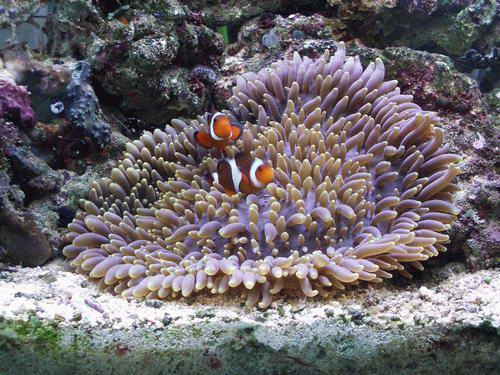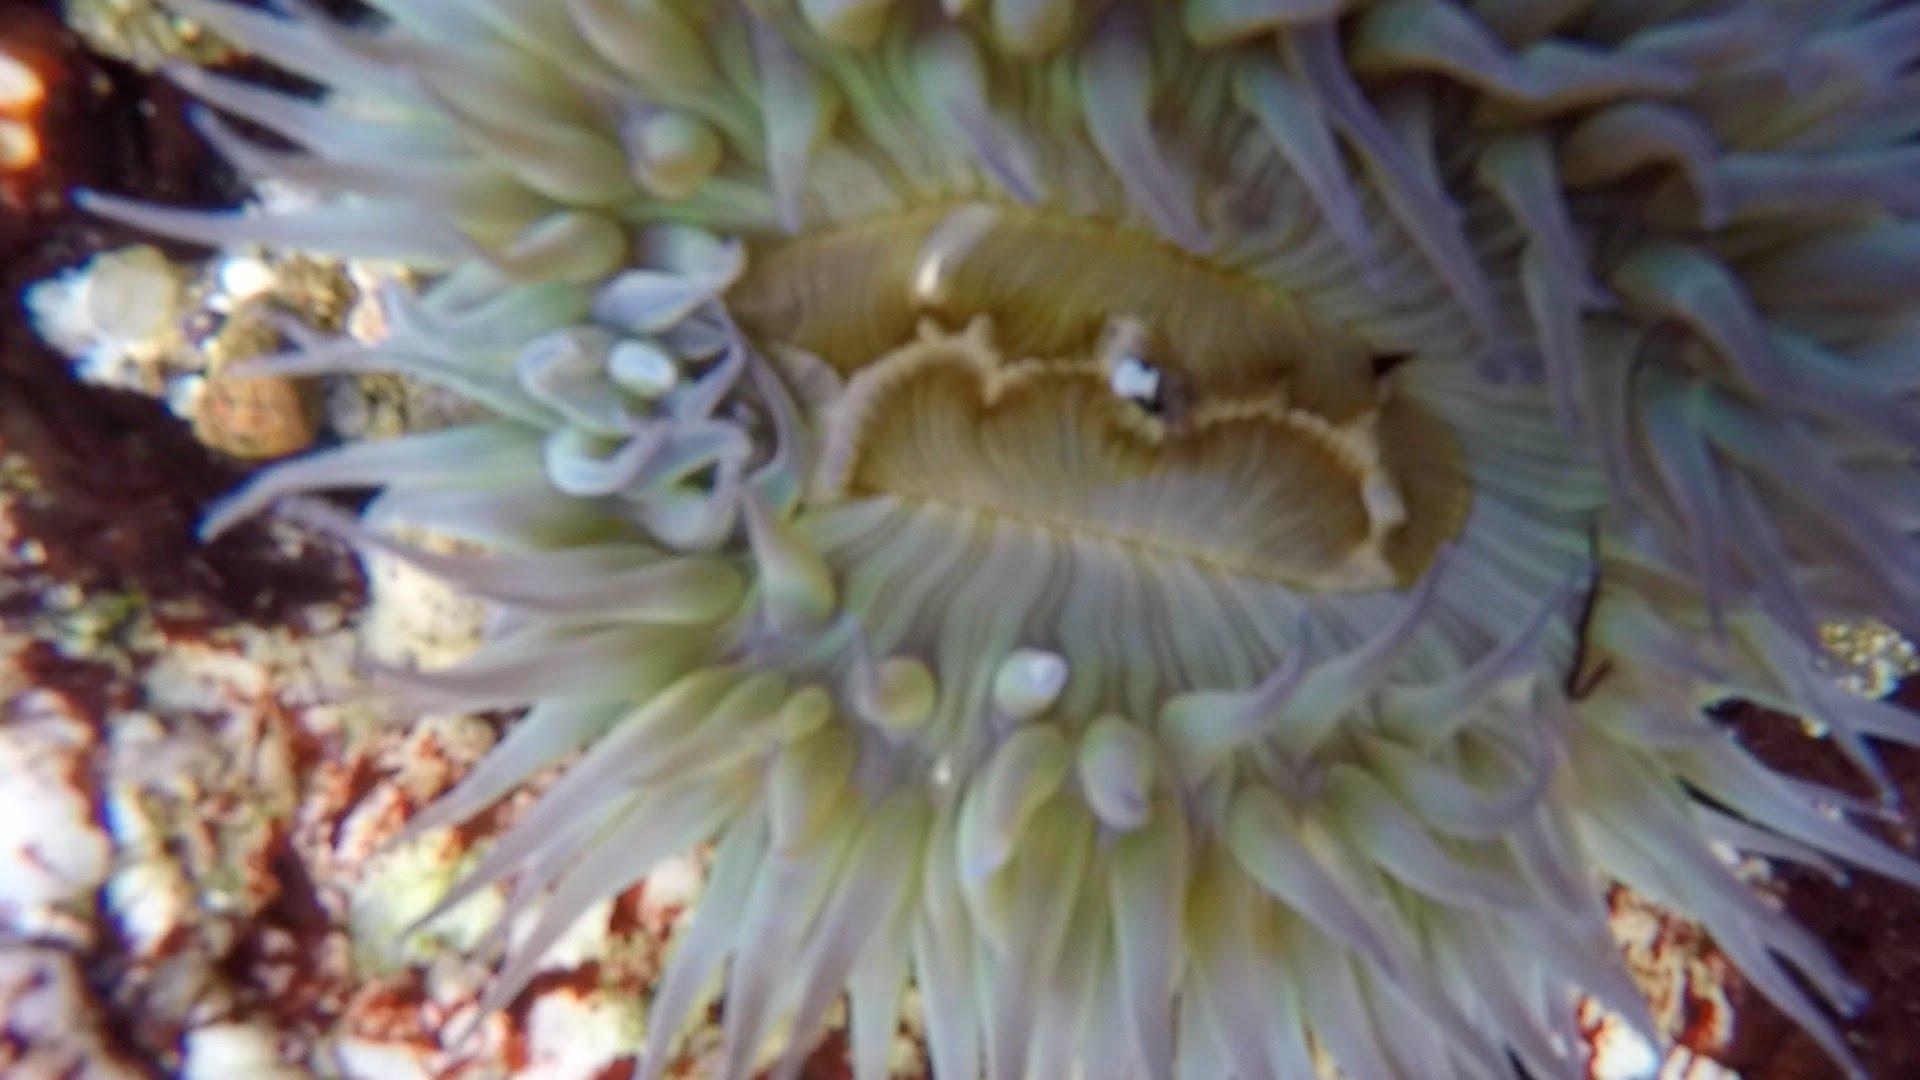The first image is the image on the left, the second image is the image on the right. Given the left and right images, does the statement "At least one fish with bold stripes is positioned over the tendrils of an anemone in the left image." hold true? Answer yes or no. Yes. The first image is the image on the left, the second image is the image on the right. For the images shown, is this caption "In at least one image there is at least one striped fish  swimming in corral." true? Answer yes or no. Yes. 